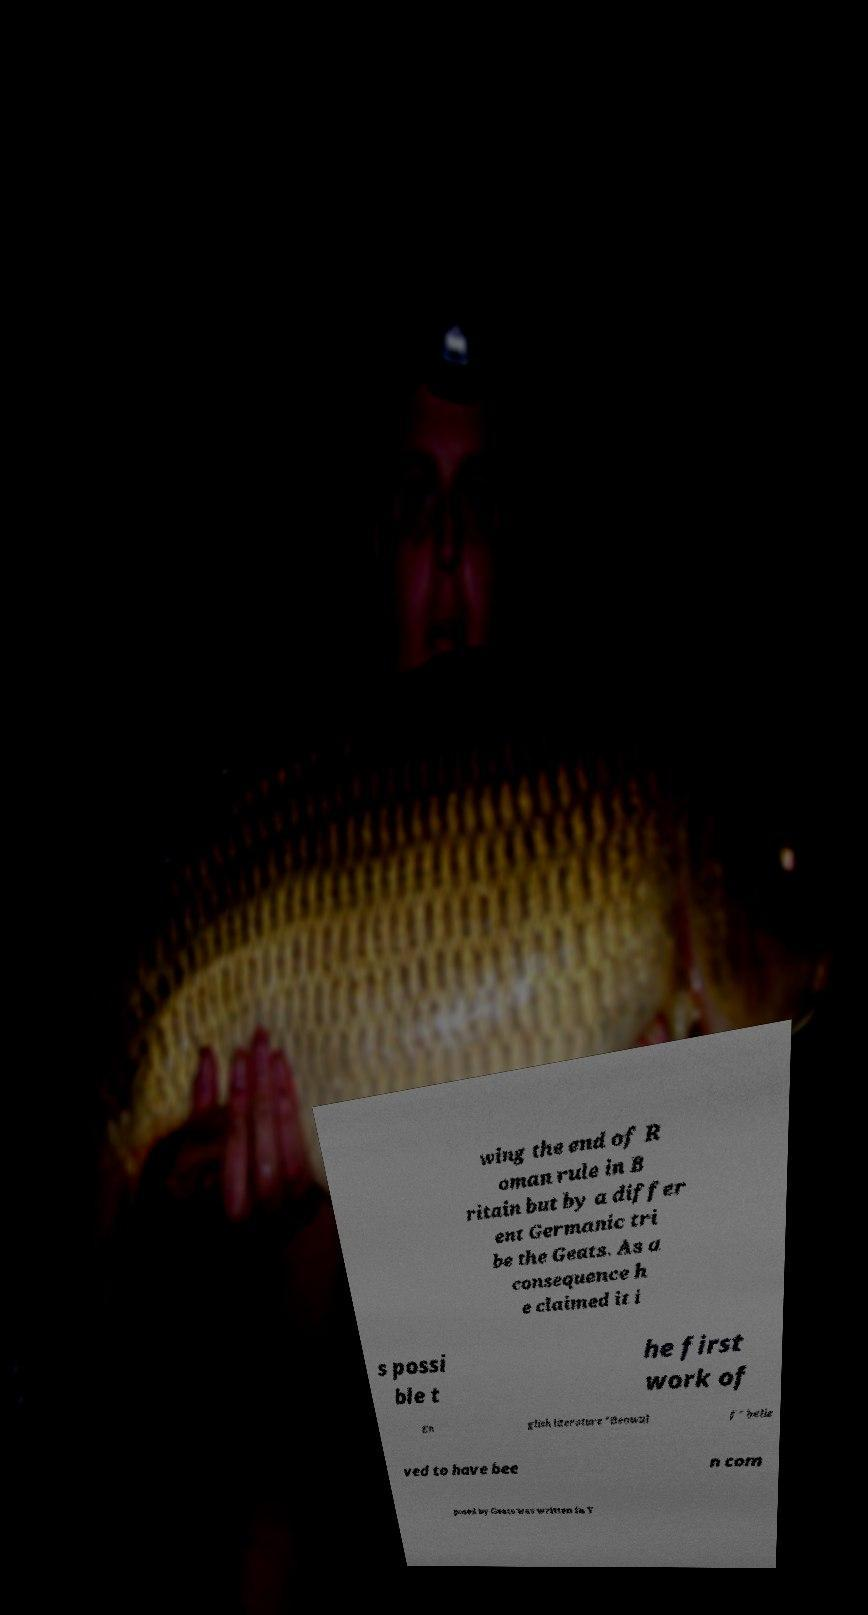Can you accurately transcribe the text from the provided image for me? wing the end of R oman rule in B ritain but by a differ ent Germanic tri be the Geats. As a consequence h e claimed it i s possi ble t he first work of En glish literature "Beowul f" belie ved to have bee n com posed by Geats was written in Y 